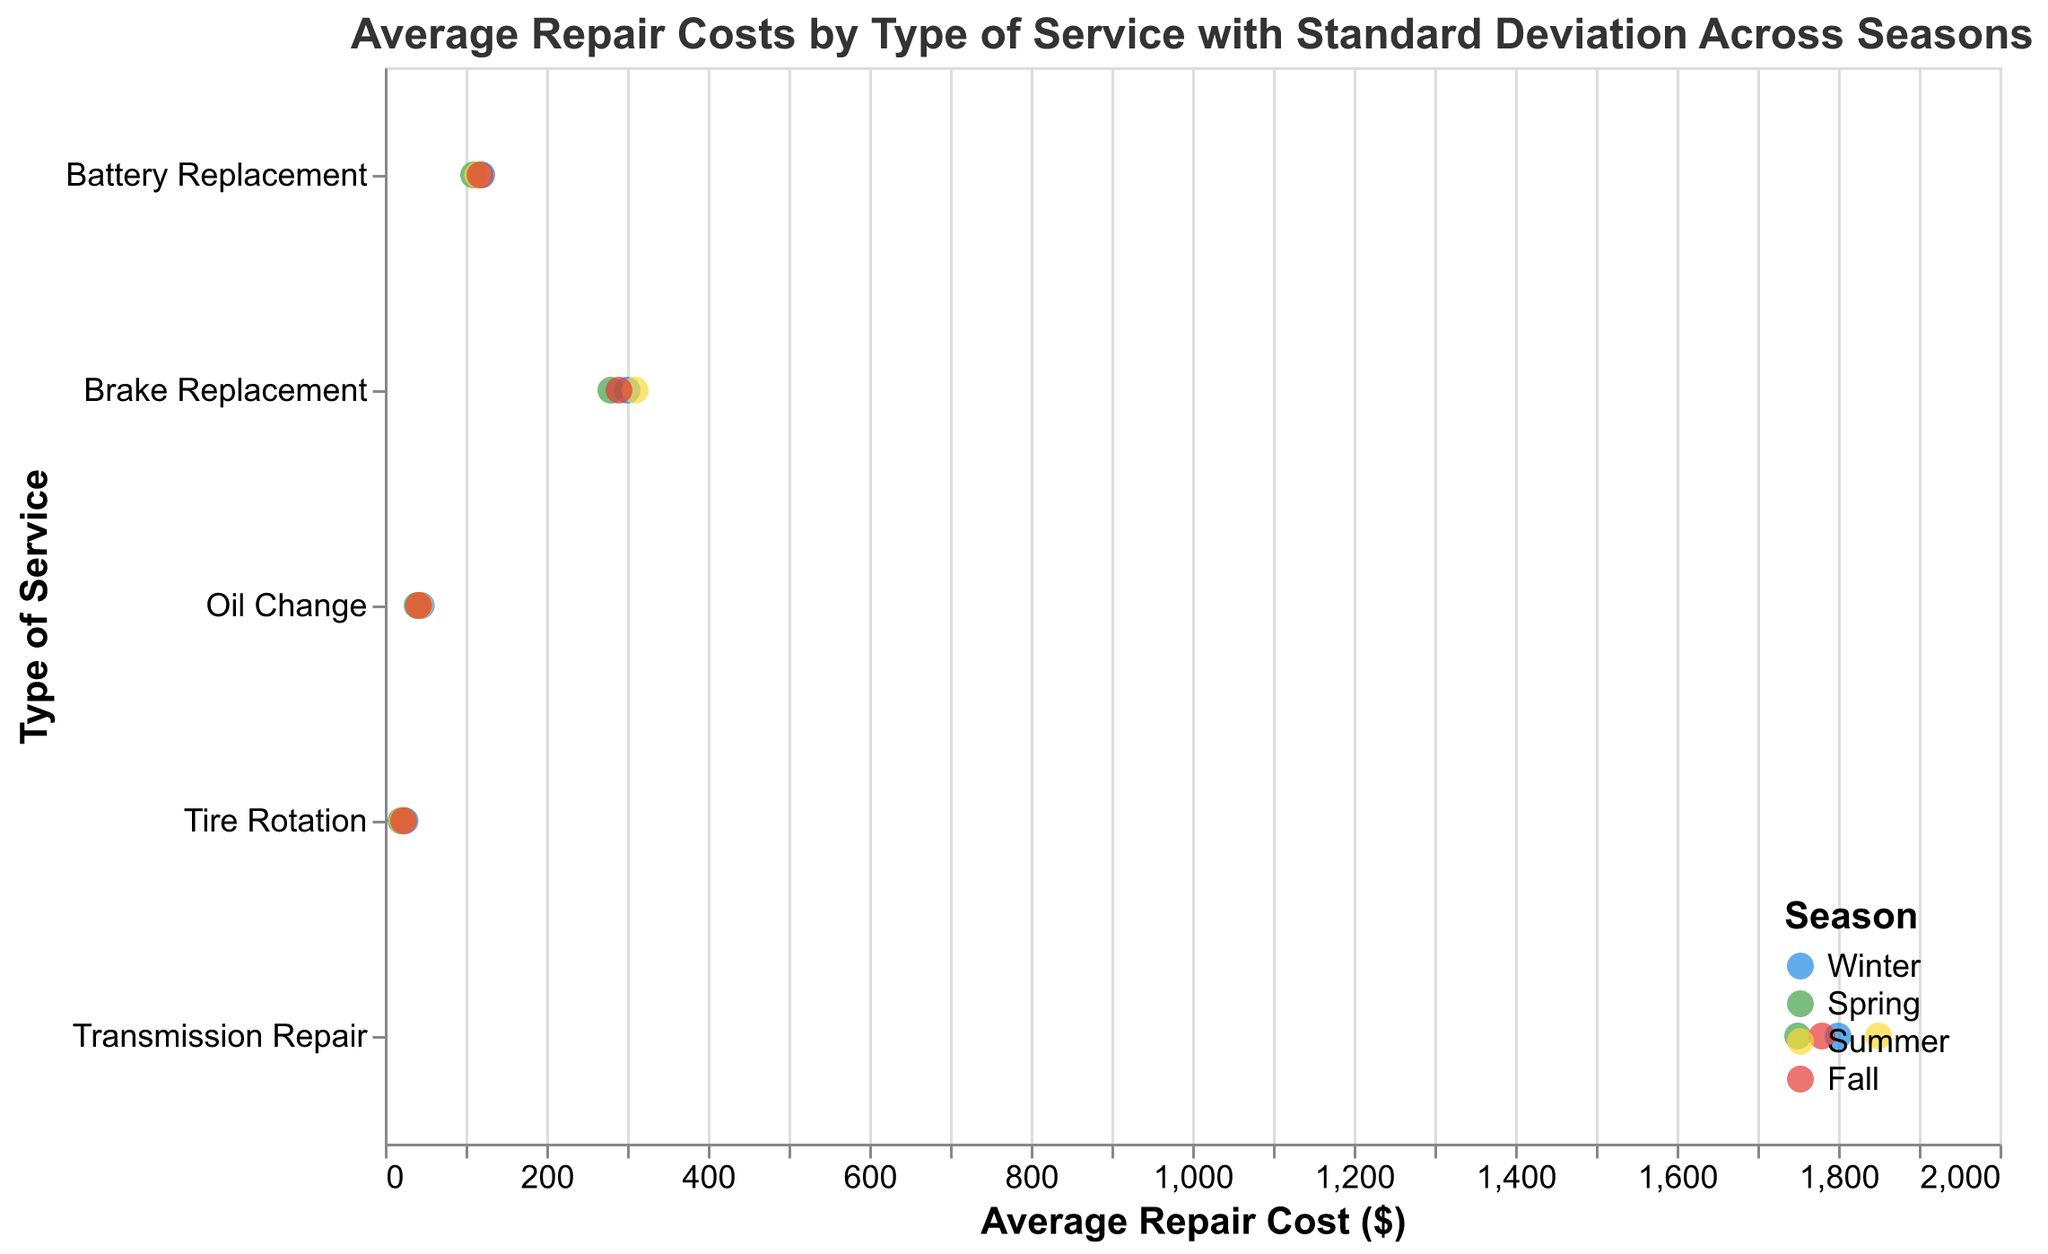What is the title of the plot? The title is located at the top of the plot and provides an overview of the content of the figure. The title reads, "Average Repair Costs by Type of Service with Standard Deviation Across Seasons."
Answer: Average Repair Costs by Type of Service with Standard Deviation Across Seasons Which season has the highest average repair cost for Transmission Repair? By looking at the points on the plot for Transmission Repair, identify the season corresponding to the highest average repair cost. Summer has the highest average repair cost for Transmission Repair at $1850.
Answer: Summer What is the standard deviation of average repair costs for Brake Replacement in Winter? Locate the data point for Brake Replacement in Winter and read the value of the standard deviation displayed in the tooltip when hovering over the point. It is 25.
Answer: 25 Which type of service has the largest spread in average repair costs throughout the seasons? Observe the extent of the error bars (representing standard deviation) for each type of service. Transmission Repair has the most extensive spread given its higher standard deviations spanning from the mid-1600s to over 2000 dollars.
Answer: Transmission Repair What is the difference in average repair cost for Brake Replacement between Summer and Spring? Reference the points representing Brake Replacement in Summer ($310) and Spring ($280), then subtract Spring’s average cost from Summer’s. The difference is 310 - 280 = 30.
Answer: 30 How does the average cost of Tire Rotation compare between Winter and Summer? Compare the average repair cost points for Tire Rotation in Winter ($25) and Summer ($22). Winter is higher by 3 dollars.
Answer: Winter is higher by $3 Which service type shows the least variability in average repair cost across the seasons? Look for the service type with the smallest error bars. Tire Rotation has the smallest error bars, indicating the least variability.
Answer: Tire Rotation How do the standard deviations of Battery Replacement in Fall and Spring compare? Check the standard deviations for Battery Replacement in Fall (11) and Spring (10). The Fall's standard deviation is higher than Spring's.
Answer: Fall has a higher standard deviation What is the total range of average repair costs for Brake Replacement across the seasons? Identify the minimum (Spring, $280) and maximum (Summer, $310) average costs for Brake Replacement and calculate the range by subtracting the minimum from the maximum. The range is 310 - 280 = 30.
Answer: 30 During which season is the average repair cost for an Oil Change the lowest? Compare the average repair costs for Oil Change across the seasons. Spring has the lowest average cost at $40.
Answer: Spring 